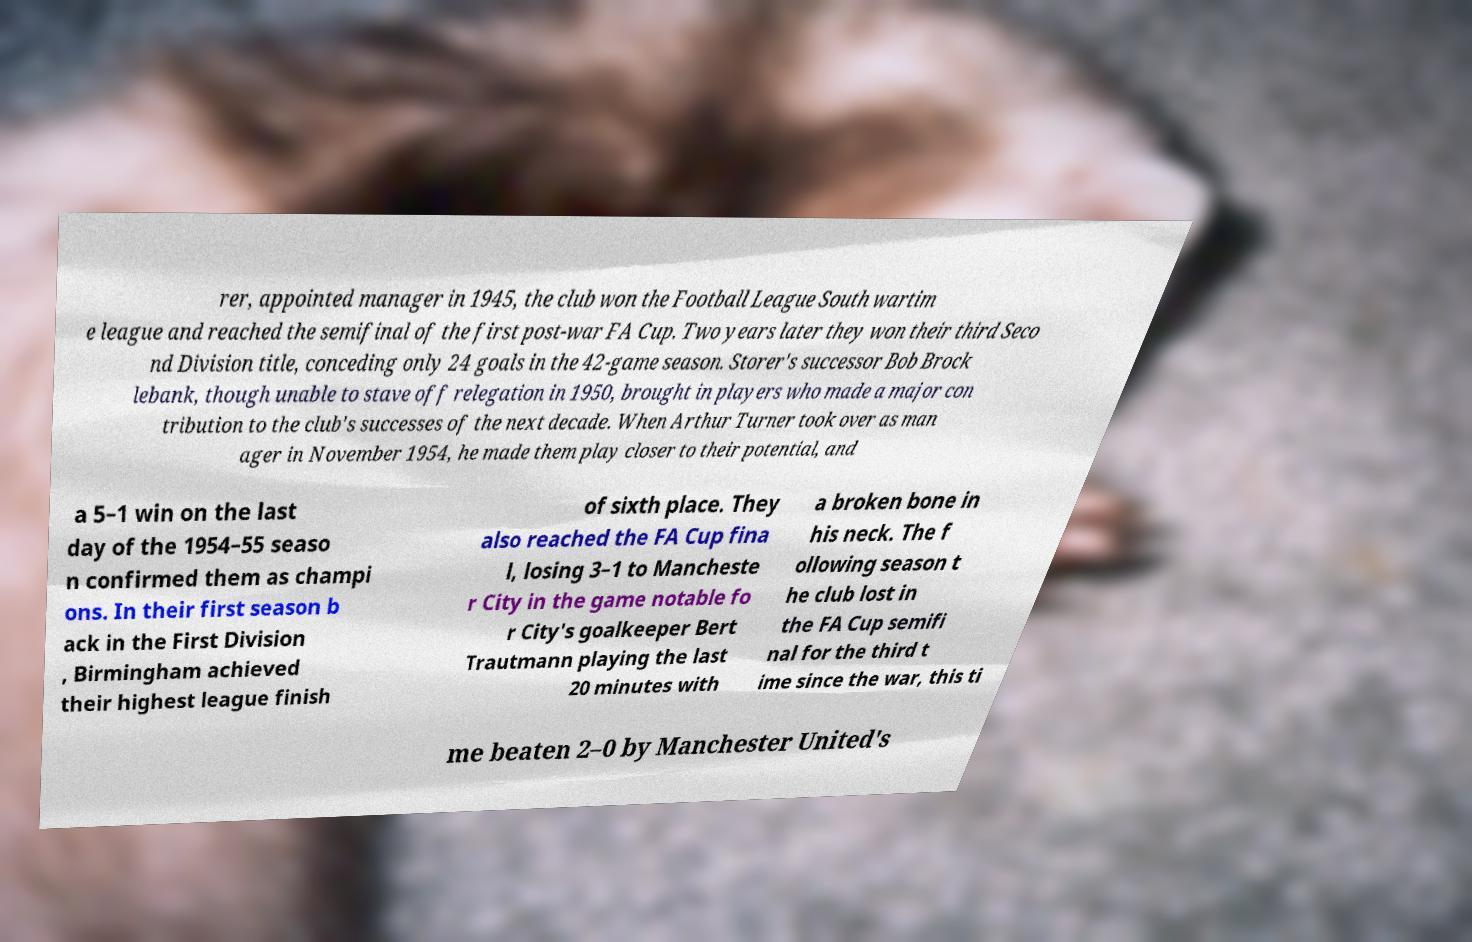Could you extract and type out the text from this image? rer, appointed manager in 1945, the club won the Football League South wartim e league and reached the semifinal of the first post-war FA Cup. Two years later they won their third Seco nd Division title, conceding only 24 goals in the 42-game season. Storer's successor Bob Brock lebank, though unable to stave off relegation in 1950, brought in players who made a major con tribution to the club's successes of the next decade. When Arthur Turner took over as man ager in November 1954, he made them play closer to their potential, and a 5–1 win on the last day of the 1954–55 seaso n confirmed them as champi ons. In their first season b ack in the First Division , Birmingham achieved their highest league finish of sixth place. They also reached the FA Cup fina l, losing 3–1 to Mancheste r City in the game notable fo r City's goalkeeper Bert Trautmann playing the last 20 minutes with a broken bone in his neck. The f ollowing season t he club lost in the FA Cup semifi nal for the third t ime since the war, this ti me beaten 2–0 by Manchester United's 